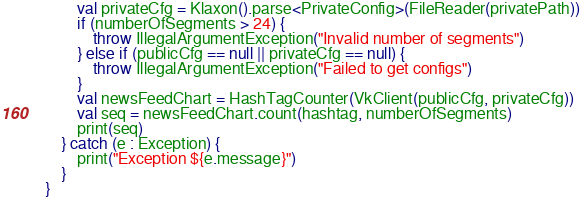Convert code to text. <code><loc_0><loc_0><loc_500><loc_500><_Kotlin_>        val privateCfg = Klaxon().parse<PrivateConfig>(FileReader(privatePath))
        if (numberOfSegments > 24) {
            throw IllegalArgumentException("Invalid number of segments")
        } else if (publicCfg == null || privateCfg == null) {
            throw IllegalArgumentException("Failed to get configs")
        }
        val newsFeedChart = HashTagCounter(VkClient(publicCfg, privateCfg))
        val seq = newsFeedChart.count(hashtag, numberOfSegments)
        print(seq)
    } catch (e : Exception) {
        print("Exception ${e.message}")
    }
}</code> 